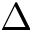<formula> <loc_0><loc_0><loc_500><loc_500>\Delta</formula> 